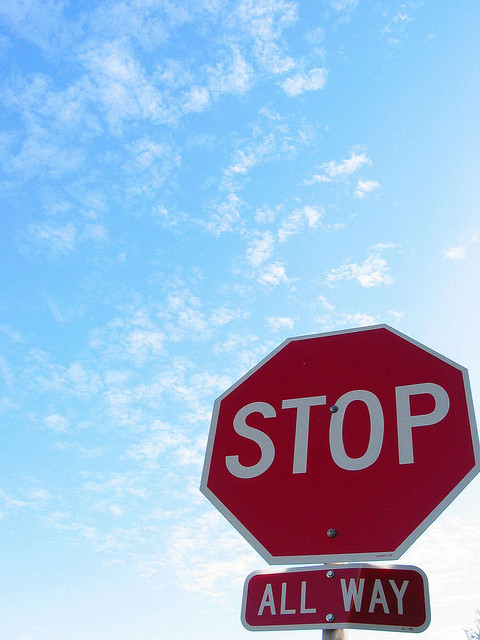<image>Where is the graffiti? There is no graffiti in the image. What street name is displayed on the sign? There is no street name displayed on the sign. Where is the graffiti? There is no graffiti in the image. What street name is displayed on the sign? There is no street name displayed on the sign. 